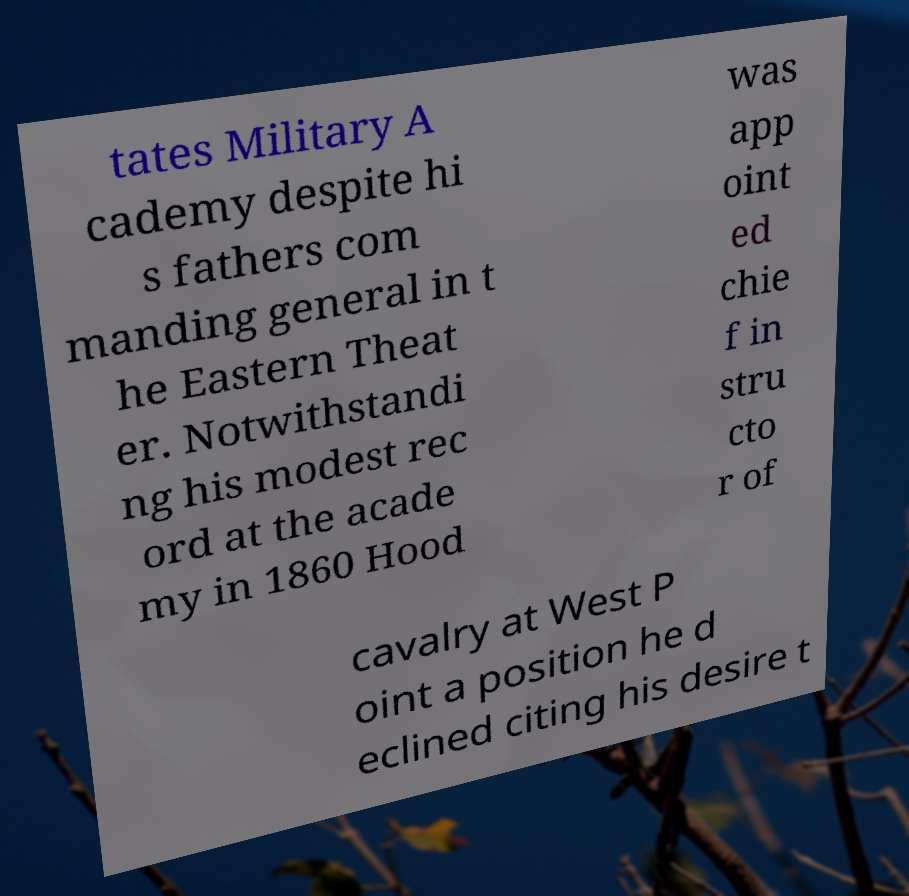I need the written content from this picture converted into text. Can you do that? tates Military A cademy despite hi s fathers com manding general in t he Eastern Theat er. Notwithstandi ng his modest rec ord at the acade my in 1860 Hood was app oint ed chie f in stru cto r of cavalry at West P oint a position he d eclined citing his desire t 